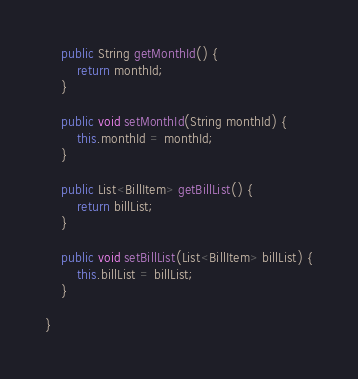Convert code to text. <code><loc_0><loc_0><loc_500><loc_500><_Java_>
	public String getMonthId() {
		return monthId;
	}

	public void setMonthId(String monthId) {
		this.monthId = monthId;
	}

	public List<BillItem> getBillList() {
		return billList;
	}

	public void setBillList(List<BillItem> billList) {
		this.billList = billList;
	}

}
</code> 